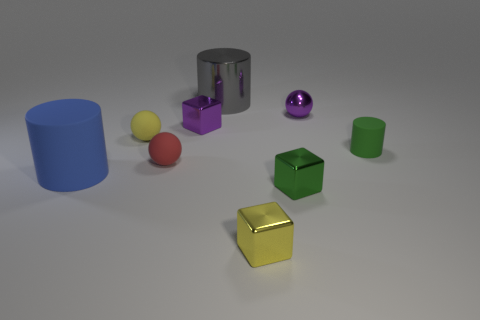There is a shiny object that is to the right of the tiny green cube; is its color the same as the cube that is behind the green rubber cylinder?
Give a very brief answer. Yes. What number of other things are there of the same color as the small metallic sphere?
Make the answer very short. 1. There is a metallic object that is the same shape as the red rubber thing; what color is it?
Your answer should be compact. Purple. What is the color of the ball that is the same material as the gray object?
Your answer should be compact. Purple. Is there a tiny green shiny thing that is behind the rubber cylinder on the right side of the large cylinder to the right of the large blue rubber cylinder?
Give a very brief answer. No. Are there fewer tiny cubes behind the yellow metal block than rubber objects on the left side of the tiny purple block?
Make the answer very short. Yes. How many big blue objects have the same material as the large blue cylinder?
Offer a very short reply. 0. Does the blue thing have the same size as the gray shiny thing on the right side of the small yellow matte sphere?
Your response must be concise. Yes. There is a yellow metal cube that is in front of the green object that is in front of the large thing that is left of the red sphere; what size is it?
Keep it short and to the point. Small. Is the number of red things left of the gray cylinder greater than the number of large matte cylinders that are behind the yellow rubber object?
Your response must be concise. Yes. 